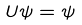<formula> <loc_0><loc_0><loc_500><loc_500>U \psi = \psi</formula> 